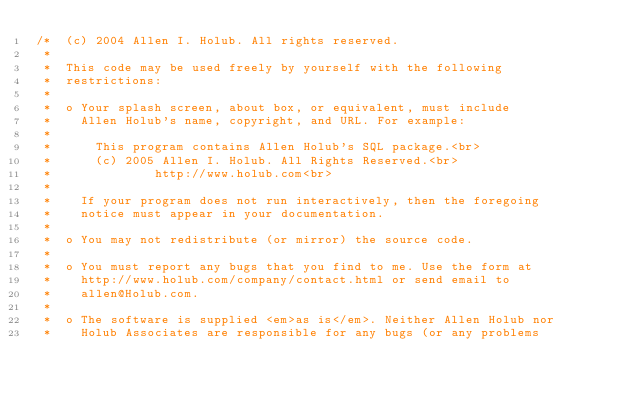Convert code to text. <code><loc_0><loc_0><loc_500><loc_500><_Java_>/*  (c) 2004 Allen I. Holub. All rights reserved.
 *
 *  This code may be used freely by yourself with the following
 *  restrictions:
 *
 *  o Your splash screen, about box, or equivalent, must include
 *    Allen Holub's name, copyright, and URL. For example:
 *
 *      This program contains Allen Holub's SQL package.<br>
 *      (c) 2005 Allen I. Holub. All Rights Reserved.<br>
 *              http://www.holub.com<br>
 *
 *    If your program does not run interactively, then the foregoing
 *    notice must appear in your documentation.
 *
 *  o You may not redistribute (or mirror) the source code.
 *
 *  o You must report any bugs that you find to me. Use the form at
 *    http://www.holub.com/company/contact.html or send email to
 *    allen@Holub.com.
 *
 *  o The software is supplied <em>as is</em>. Neither Allen Holub nor
 *    Holub Associates are responsible for any bugs (or any problems</code> 